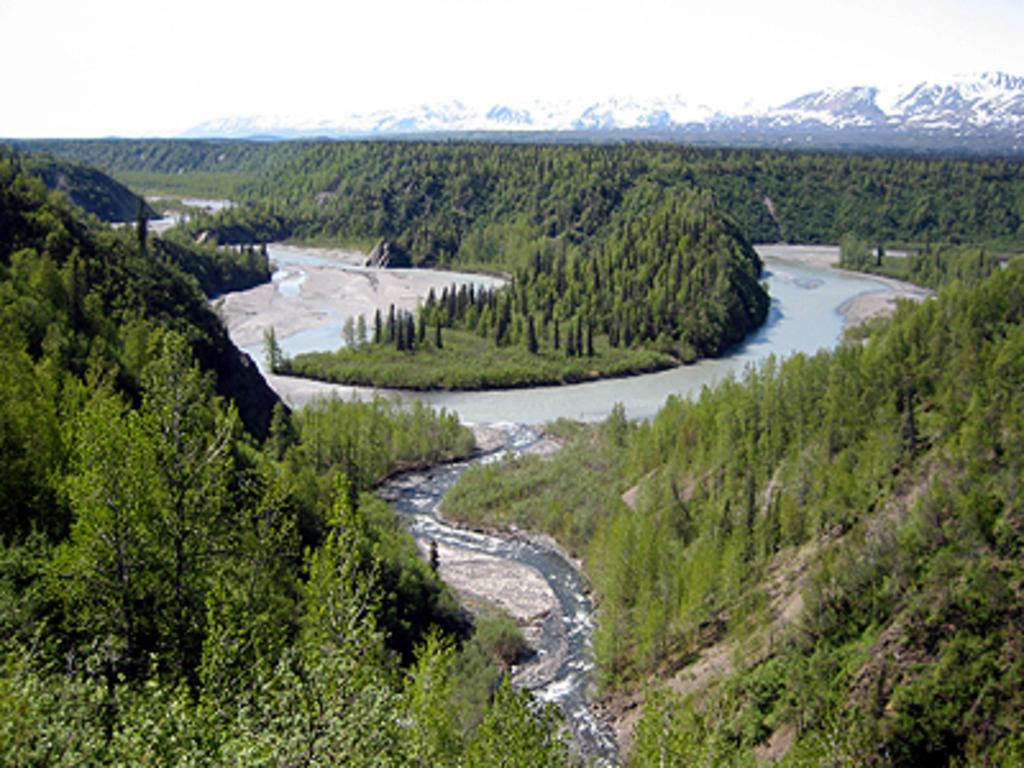What type of natural feature is present in the image? There is a river in the image. What other natural elements can be seen in the image? There is a group of trees and ice hills visible in the image. What is visible in the background of the image? The sky is visible in the image. Can you see any keys or shoes in the image? No, there are no keys or shoes present in the image. Are there any giants visible in the image? No, there are no giants present in the image. 